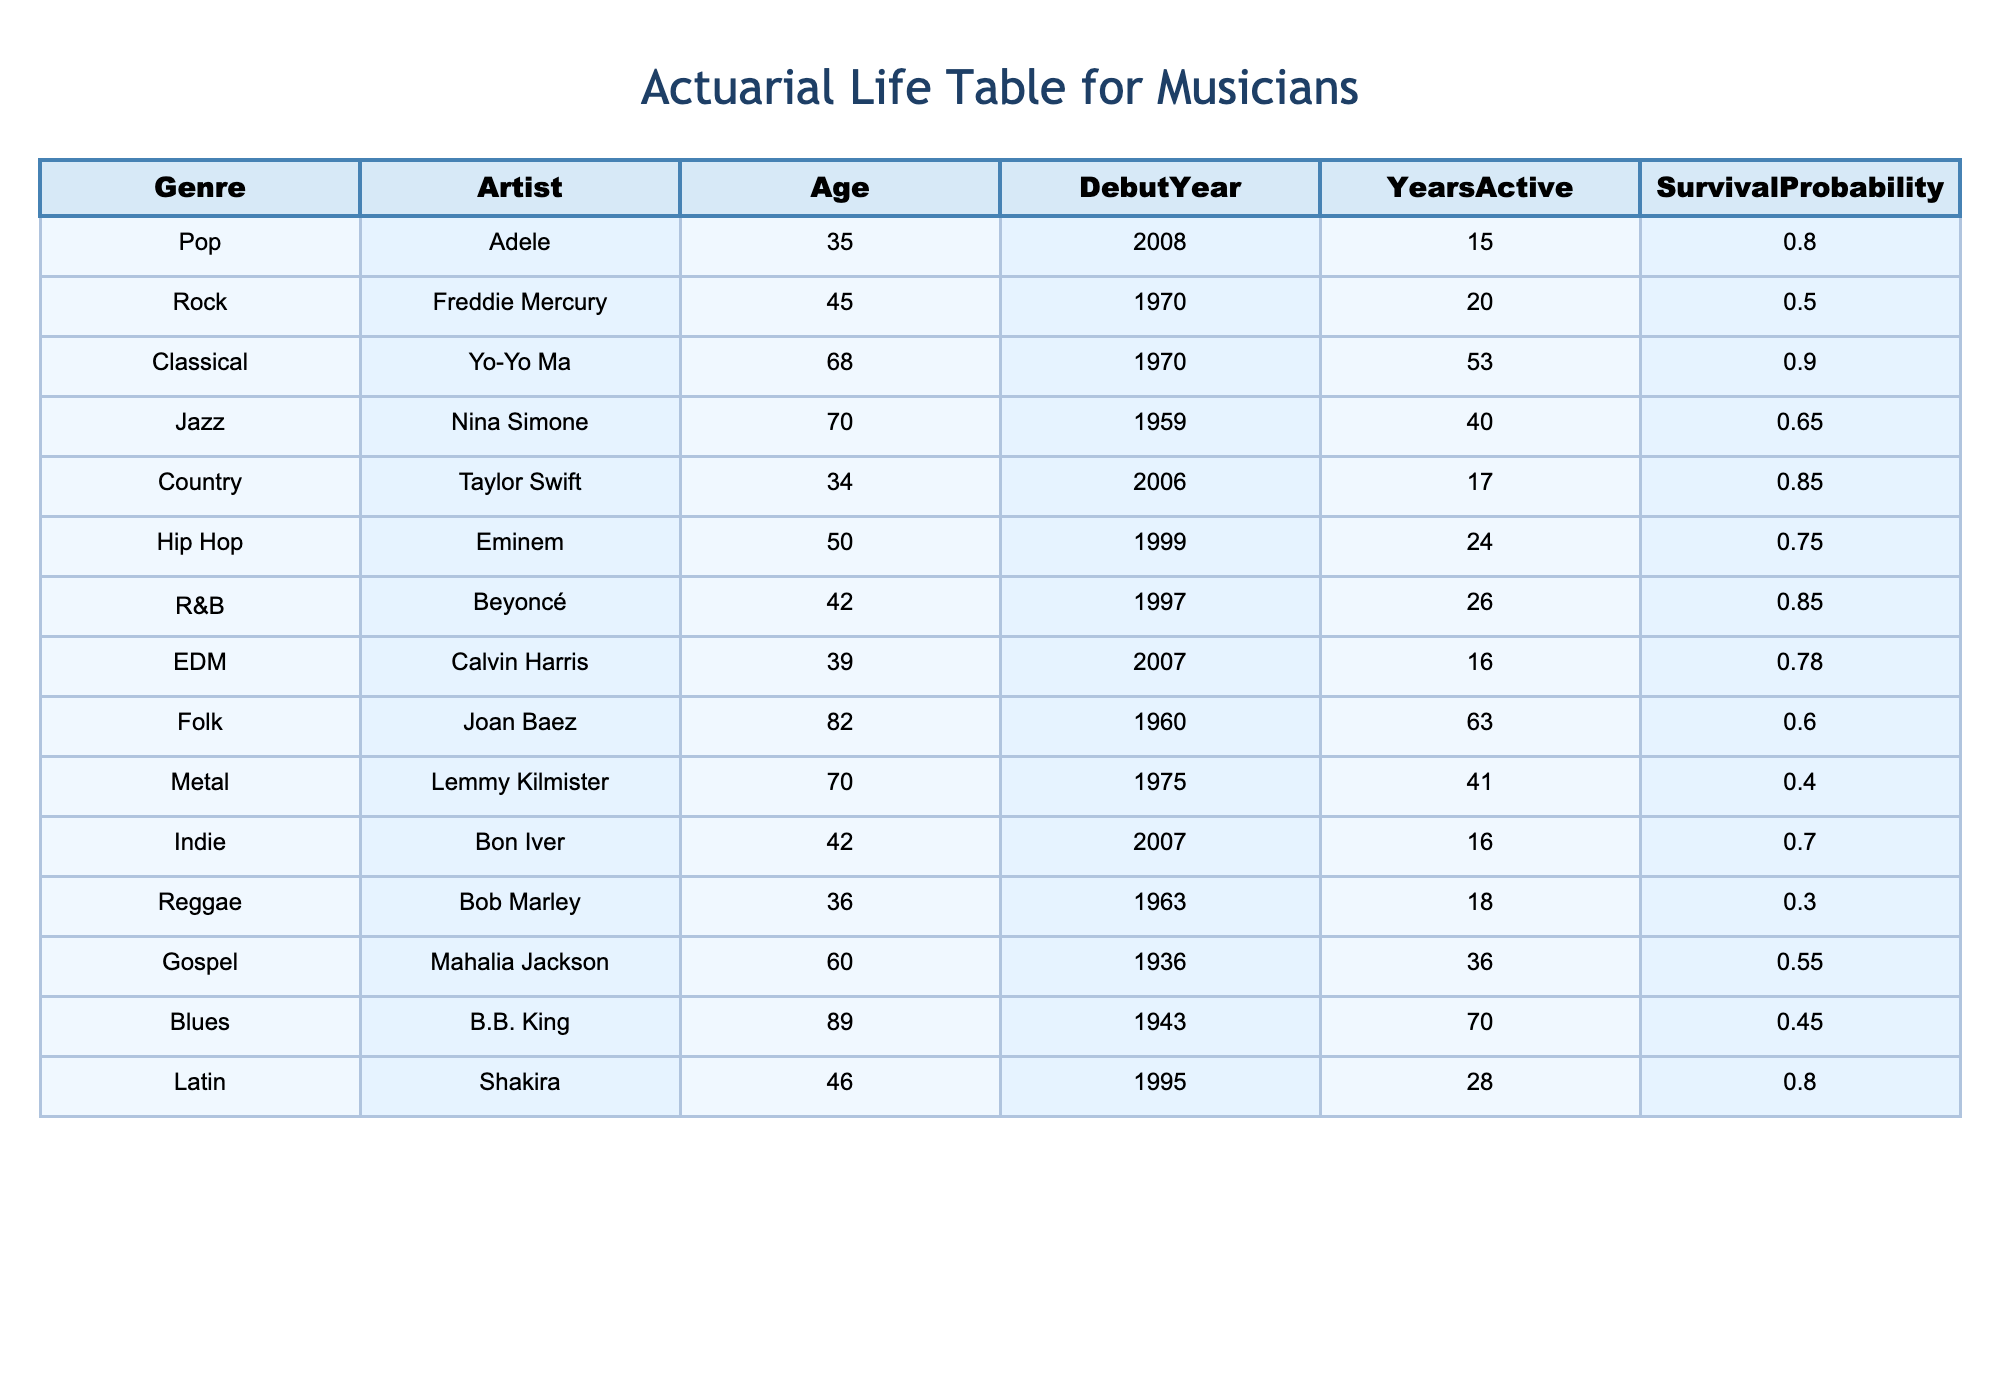What is the survival probability of Eminem? The survival probability of Eminem is explicitly listed in the table as 0.75.
Answer: 0.75 Who is the oldest artist in the table? The oldest artist listed is B.B. King, who is 89 years old.
Answer: B.B. King What is the average survival probability of artists in the Pop and Country genres? The survival probability of Pop (Adele, 0.80) and Country (Taylor Swift, 0.85) can be averaged: (0.80 + 0.85) / 2 = 0.825.
Answer: 0.825 Is the survival probability of Mahalia Jackson greater than that of Nina Simone? Mahalia Jackson has a survival probability of 0.55, while Nina Simone's is 0.65. Since 0.55 is less than 0.65, the statement is false.
Answer: No Which genre has the highest average survival probability? To find this, calculate the average survival probabilities for each genre. Classical (0.90), Pop (0.80), R&B (0.85), and Country (0.85) all yield high averages, but Classical has the highest at 0.90.
Answer: Classical How many artists in the table have a survival probability below 0.50? By looking at the table, both Freddie Mercury and Lemmy Kilmister have survival probabilities below 0.50, totaling to 2 artists.
Answer: 2 What is the difference in survival probability between the youngest (Adele) and oldest (B.B. King) artists? Adele has a survival probability of 0.80 and B.B. King has 0.45. The difference is calculated as 0.80 - 0.45 = 0.35.
Answer: 0.35 Which genres have survival probabilities above 0.70? From the table, genres with survival probabilities above 0.70 include Classical (0.90), Pop (0.80), Country (0.85), R&B (0.85), EDM (0.78), and Indie (0.70), totaling 6 genres.
Answer: 6 Is the survival probability of Joan Baez higher than that of Bob Marley? Joan Baez has a survival probability of 0.60, while Bob Marley's is 0.30. Since 0.60 is greater than 0.30, the statement is true.
Answer: Yes 